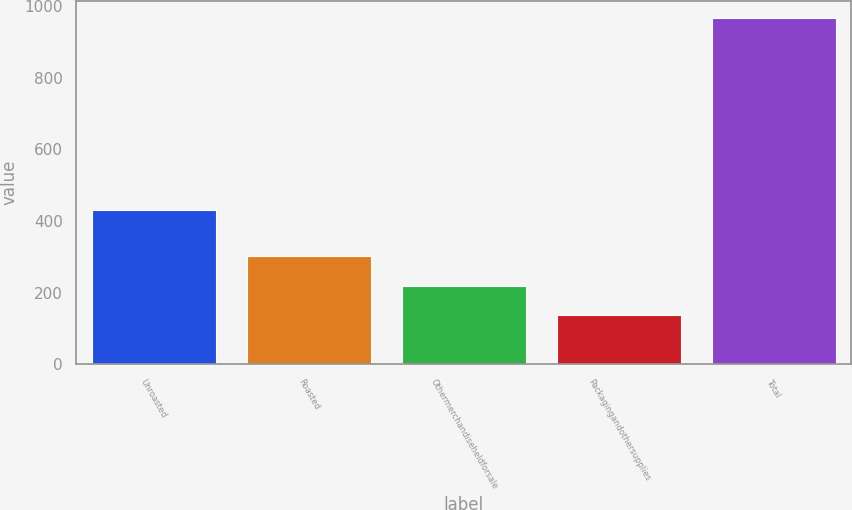<chart> <loc_0><loc_0><loc_500><loc_500><bar_chart><fcel>Unroasted<fcel>Roasted<fcel>Othermerchandiseheldforsale<fcel>Packagingandothersupplies<fcel>Total<nl><fcel>431.3<fcel>302.92<fcel>220.06<fcel>137.2<fcel>965.8<nl></chart> 